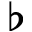<formula> <loc_0><loc_0><loc_500><loc_500>\flat</formula> 